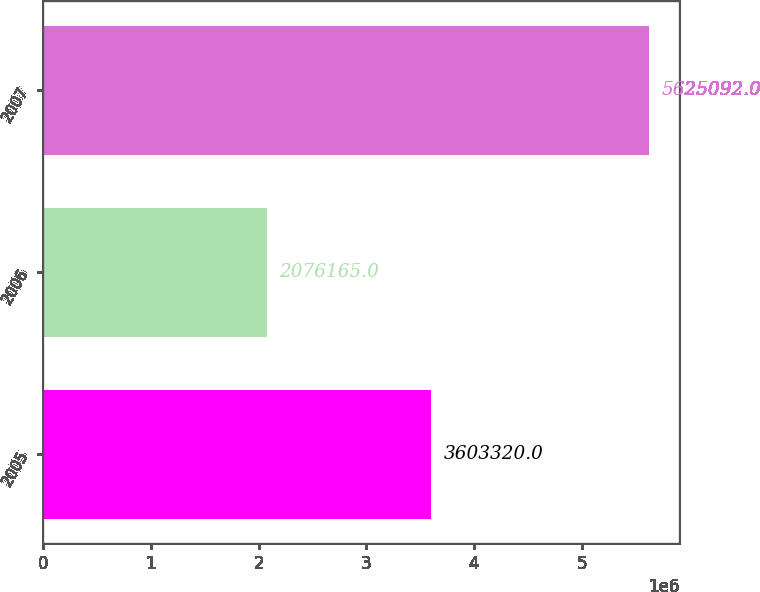Convert chart to OTSL. <chart><loc_0><loc_0><loc_500><loc_500><bar_chart><fcel>2005<fcel>2006<fcel>2007<nl><fcel>3.60332e+06<fcel>2.07616e+06<fcel>5.62509e+06<nl></chart> 